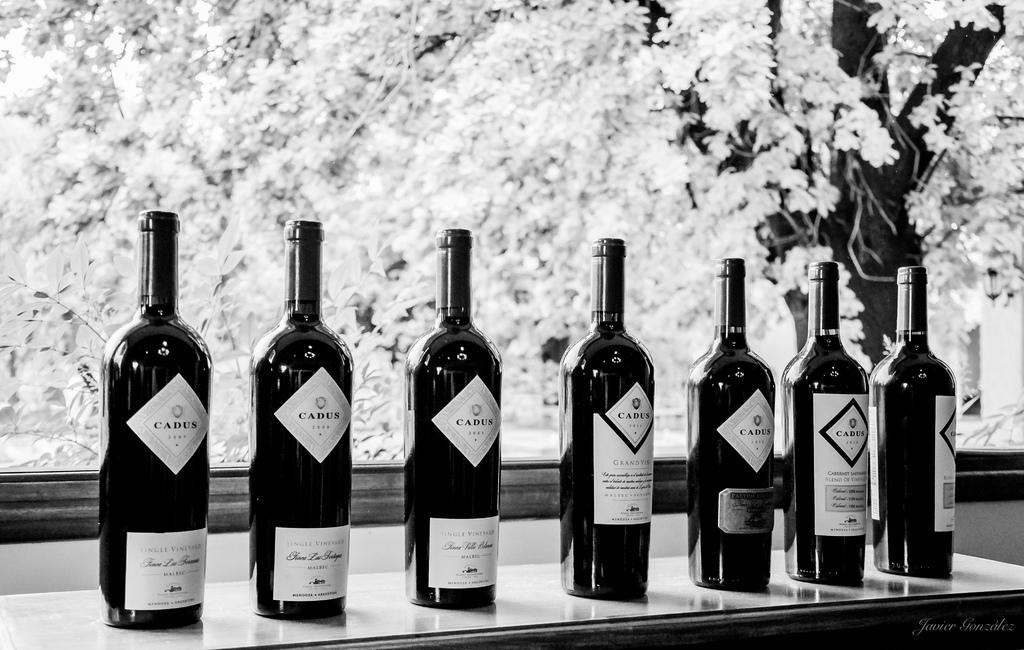What objects are placed on the wooden table in the image? There are bottles placed on a wooden table in the image. What other item can be seen in the image besides the bottles on the table? There is a photo frame in the image. What is depicted in the photo frame? The photo frame includes flowers. What type of flame can be seen burning in the image? There is no flame present in the image. What kind of produce is displayed in the photo frame? The photo frame does not contain any produce; it includes flowers. 